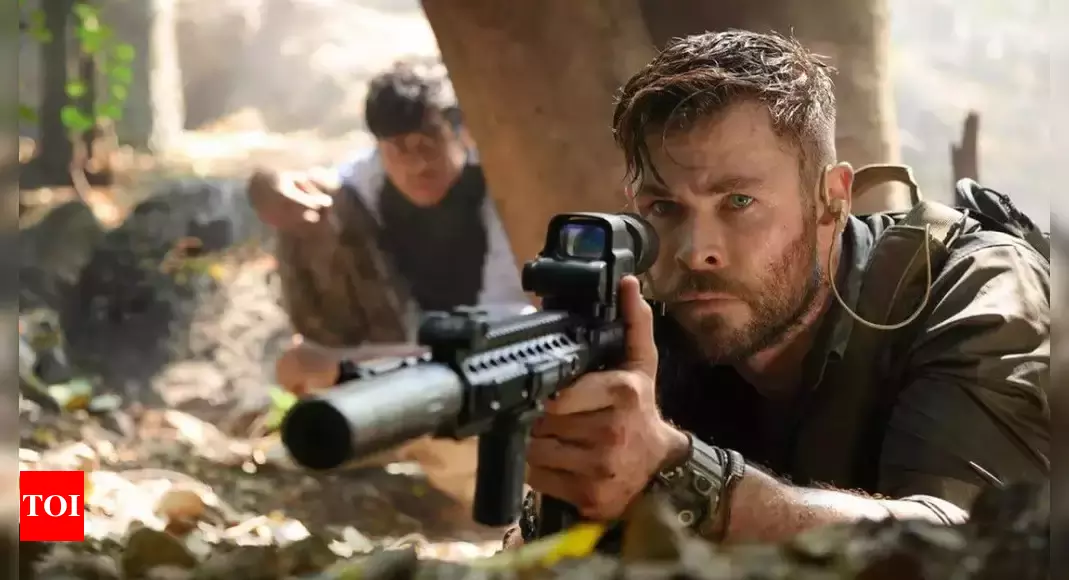Imagine if the scene was set in an urban setting instead. How would the dynamics change? If the scene were set in an urban environment, the dynamics would shift significantly. Instead of the thick, concealing foliage of a jungle, the characters might find themselves navigating through crowded streets, abandoned buildings, or strategic vantage points like rooftops. The concrete jungle would present its own challenges, such as dealing with civilians, restricted movement, and potential surveillance. The sense of unpredictability and danger would still be present but manifested in different ways, such as ambushes from alleys or sniper threats from high-rise buildings. The urban setting would transform the scene into a tactical urban warfare scenario, emphasizing stealth, strategy, and quick decision-making in a populated yet treacherous landscape. What might be the backstory of the characters depicted in this scene? The characters in this scene likely have a rich backstory filled with intense training, difficult choices, and personal motivations. The central figure, possibly a seasoned operative or soldier, has a history of numerous high-stakes missions, honing his skills in various combat scenarios. His current mission, perhaps, involves rescuing hostages or hunting down a dangerous target deep within the jungle. The person behind him could be a trusted ally or a protege he's guiding through the perilous mission. Their relationship might be built on shared experiences and mutual respect, forged in the fires of past battles. This deep bond, along with their individual skills and determination, drives them to overcome the daunting challenges they face in this high-tension situation. 